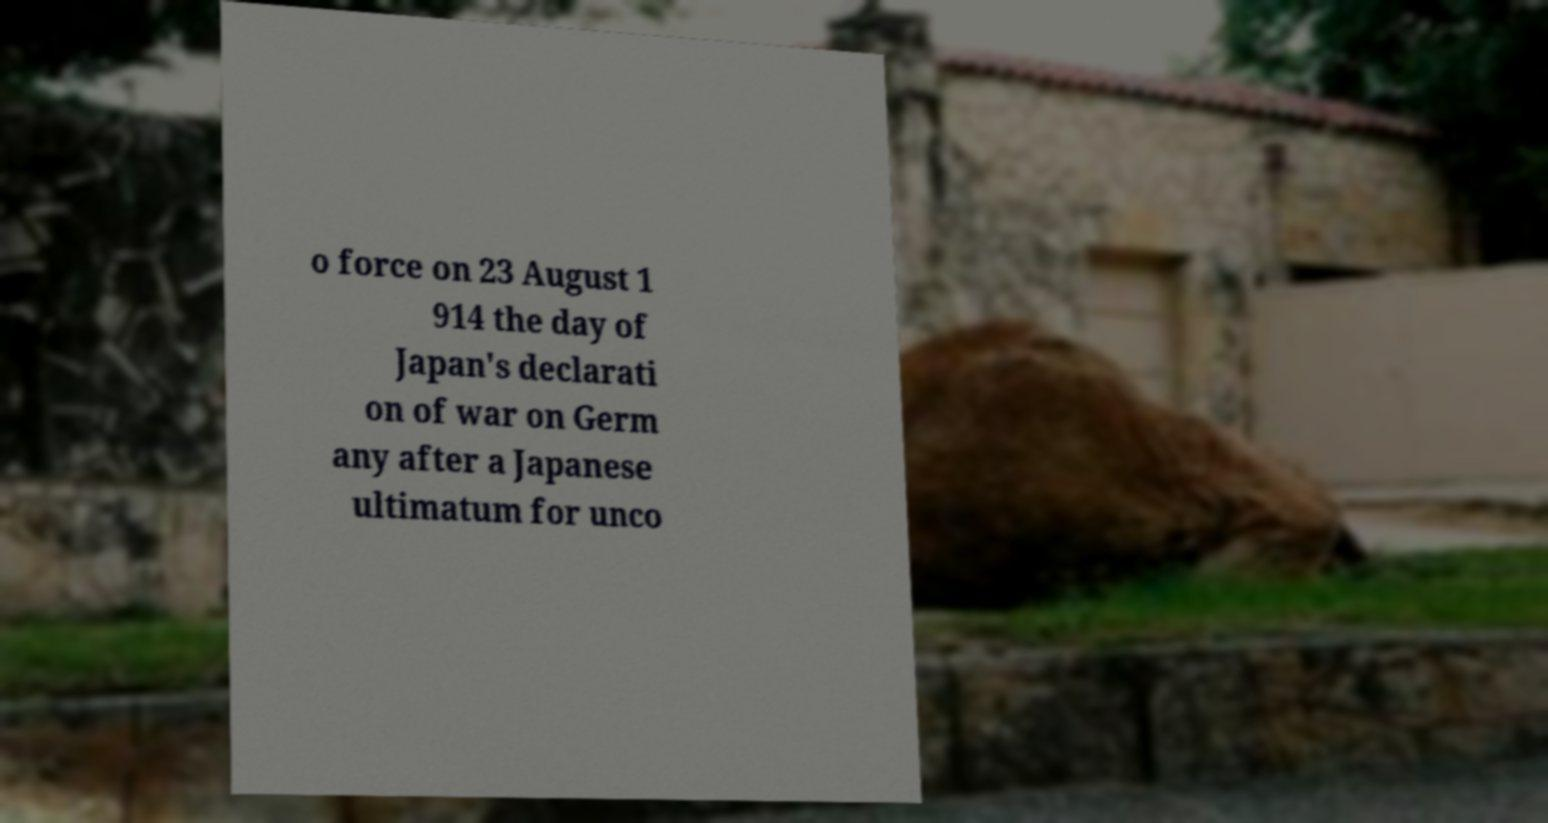For documentation purposes, I need the text within this image transcribed. Could you provide that? o force on 23 August 1 914 the day of Japan's declarati on of war on Germ any after a Japanese ultimatum for unco 